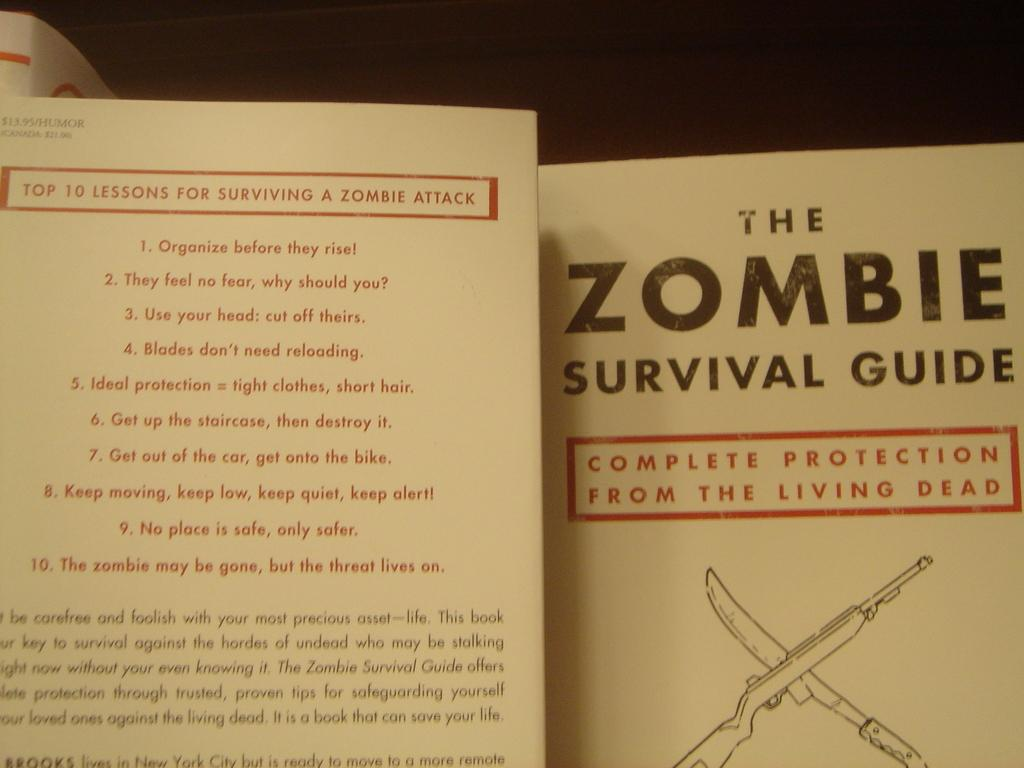What is the main object in the image? There is an instruction guide in the image. What type of content is included in the instruction guide? The instruction guide contains text. Where is the clam located in the image? There is no clam present in the image. What type of pan is used to cook the food in the image? There is no pan or food present in the image. 